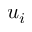<formula> <loc_0><loc_0><loc_500><loc_500>u _ { i }</formula> 